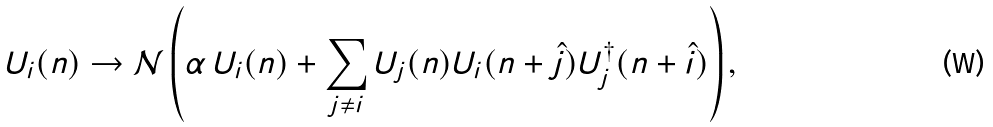Convert formula to latex. <formula><loc_0><loc_0><loc_500><loc_500>U _ { i } ( n ) \rightarrow { \mathcal { N } } \left ( \alpha \, U _ { i } ( n ) + \sum _ { j \neq i } U _ { j } ( n ) U _ { i } ( n + \hat { j } ) U _ { j } ^ { \dagger } ( n + \hat { i } ) \right ) ,</formula> 